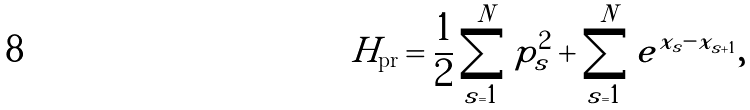Convert formula to latex. <formula><loc_0><loc_0><loc_500><loc_500>H _ { \text {pr} } = \frac { 1 } { 2 } \sum _ { s = 1 } ^ { N } p ^ { 2 } _ { s } + \sum _ { s = 1 } ^ { N } e ^ { x _ { s } - x _ { s + 1 } } ,</formula> 